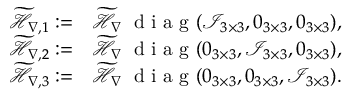Convert formula to latex. <formula><loc_0><loc_0><loc_500><loc_500>\begin{array} { r l } { \widetilde { \mathcal { H } } _ { \nabla , 1 } \colon = } & \widetilde { \mathcal { H } } _ { \nabla } \, d i a g ( \mathcal { I } _ { 3 \times 3 } , 0 _ { 3 \times 3 } , 0 _ { 3 \times 3 } ) , } \\ { \widetilde { \mathcal { H } } _ { \nabla , 2 } \colon = } & \widetilde { \mathcal { H } } _ { \nabla } \, d i a g ( 0 _ { 3 \times 3 } , \mathcal { I } _ { 3 \times 3 } , 0 _ { 3 \times 3 } ) , } \\ { \widetilde { \mathcal { H } } _ { \nabla , 3 } \colon = } & \widetilde { \mathcal { H } } _ { \nabla } \, d i a g ( 0 _ { 3 \times 3 } , 0 _ { 3 \times 3 } , \mathcal { I } _ { 3 \times 3 } ) . } \end{array}</formula> 